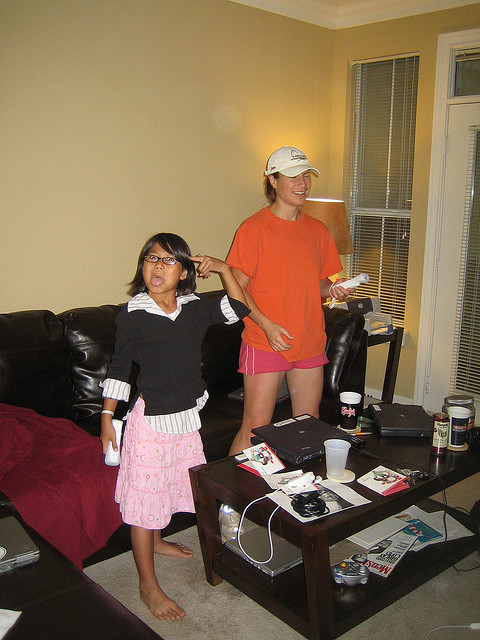Please transcribe the text information in this image. Men's 